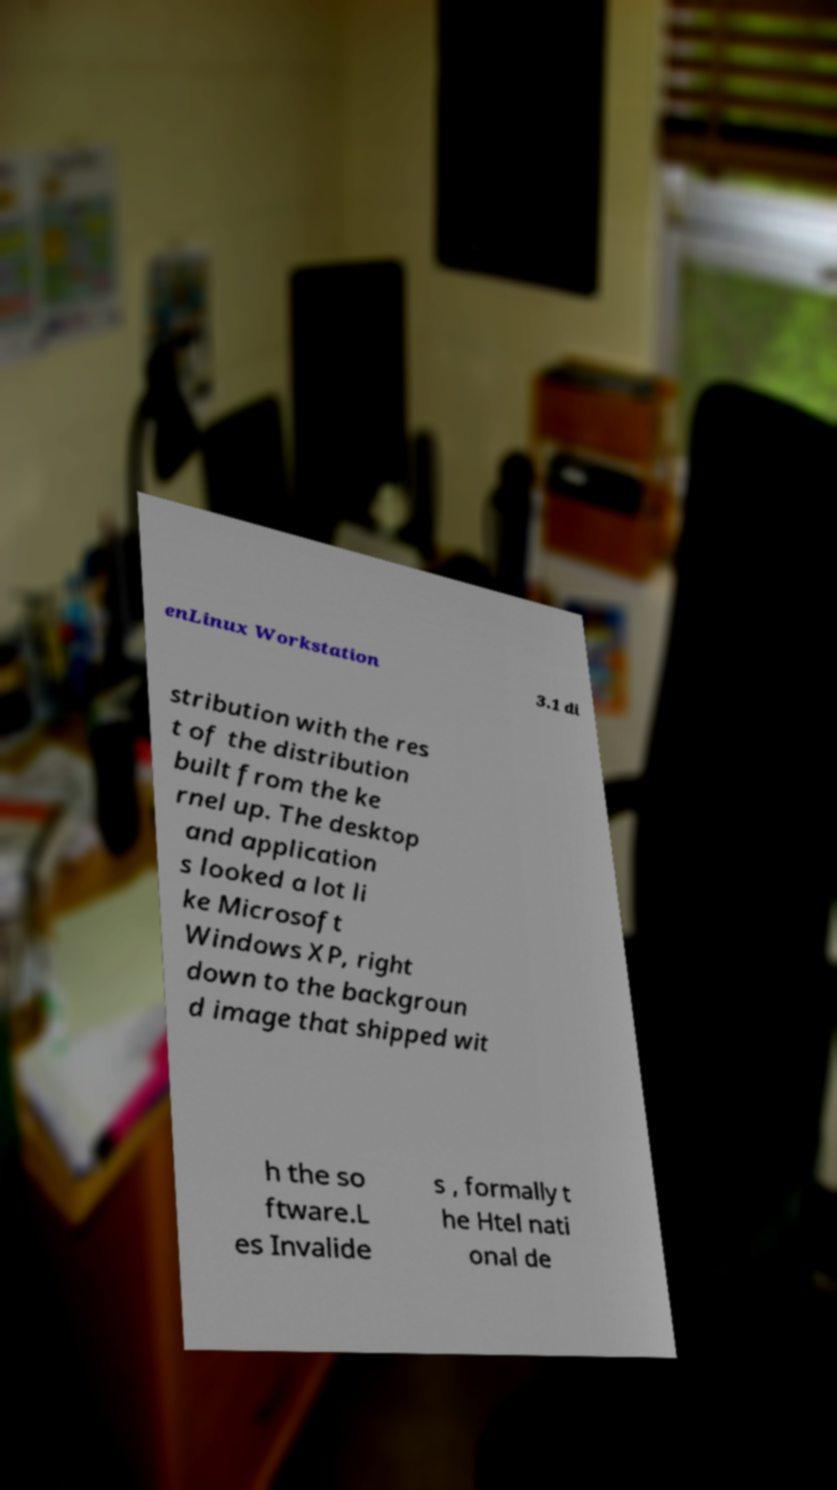What messages or text are displayed in this image? I need them in a readable, typed format. enLinux Workstation 3.1 di stribution with the res t of the distribution built from the ke rnel up. The desktop and application s looked a lot li ke Microsoft Windows XP, right down to the backgroun d image that shipped wit h the so ftware.L es Invalide s , formally t he Htel nati onal de 